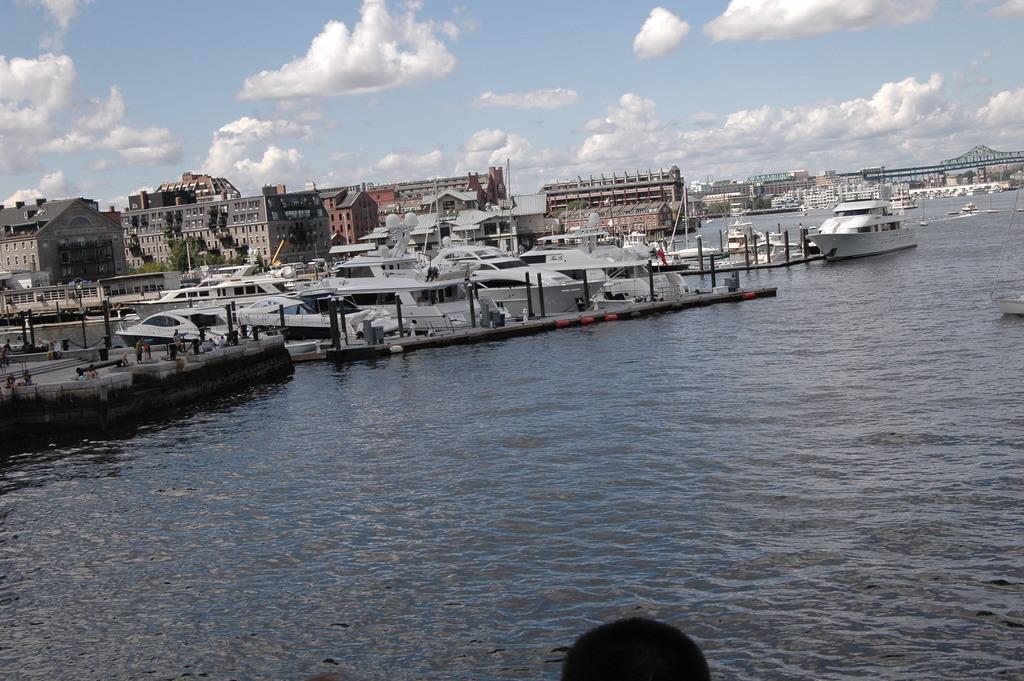Describe this image in one or two sentences. In this image, I can see the boats on the water. There are buildings and trees. On the right side of the image, I can see a bridge. In the background, there is the sky. 